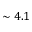Convert formula to latex. <formula><loc_0><loc_0><loc_500><loc_500>\sim 4 . 1</formula> 